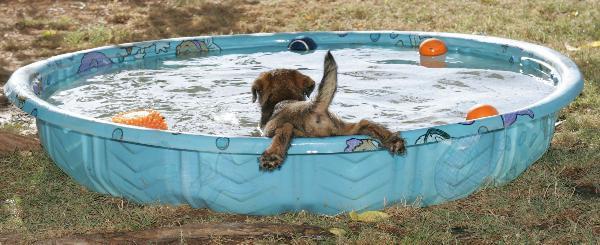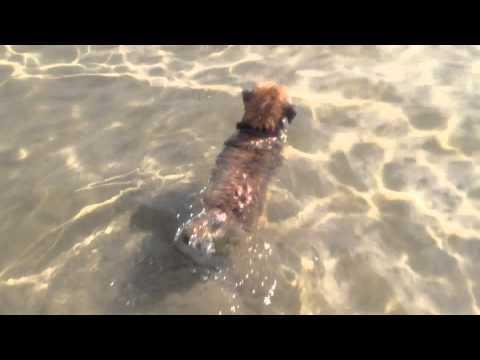The first image is the image on the left, the second image is the image on the right. Analyze the images presented: Is the assertion "A forward-headed dog is staying afloat by means of some item that floats." valid? Answer yes or no. No. The first image is the image on the left, the second image is the image on the right. Assess this claim about the two images: "The dog in the image on the left is swimming in a pool.". Correct or not? Answer yes or no. Yes. 